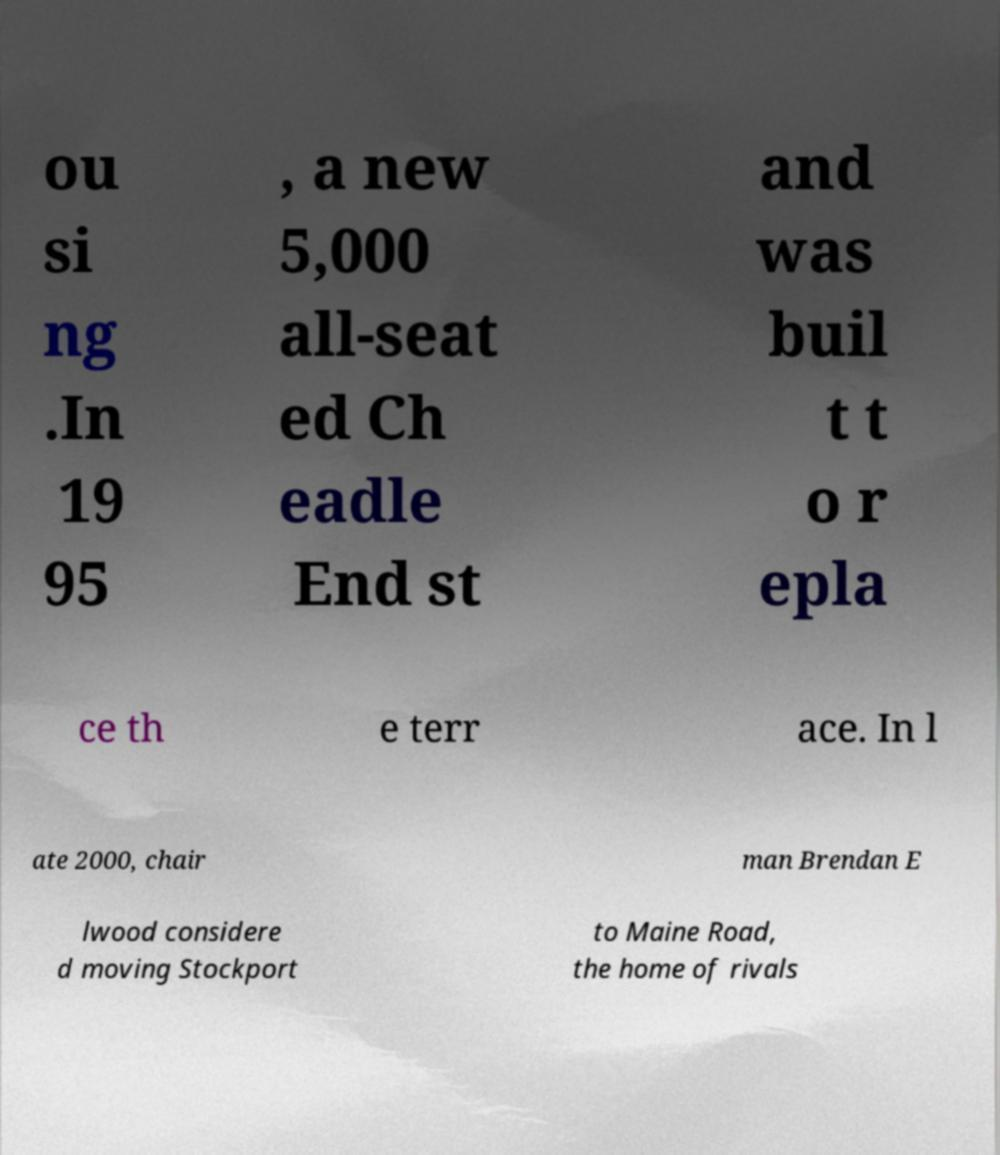For documentation purposes, I need the text within this image transcribed. Could you provide that? ou si ng .In 19 95 , a new 5,000 all-seat ed Ch eadle End st and was buil t t o r epla ce th e terr ace. In l ate 2000, chair man Brendan E lwood considere d moving Stockport to Maine Road, the home of rivals 